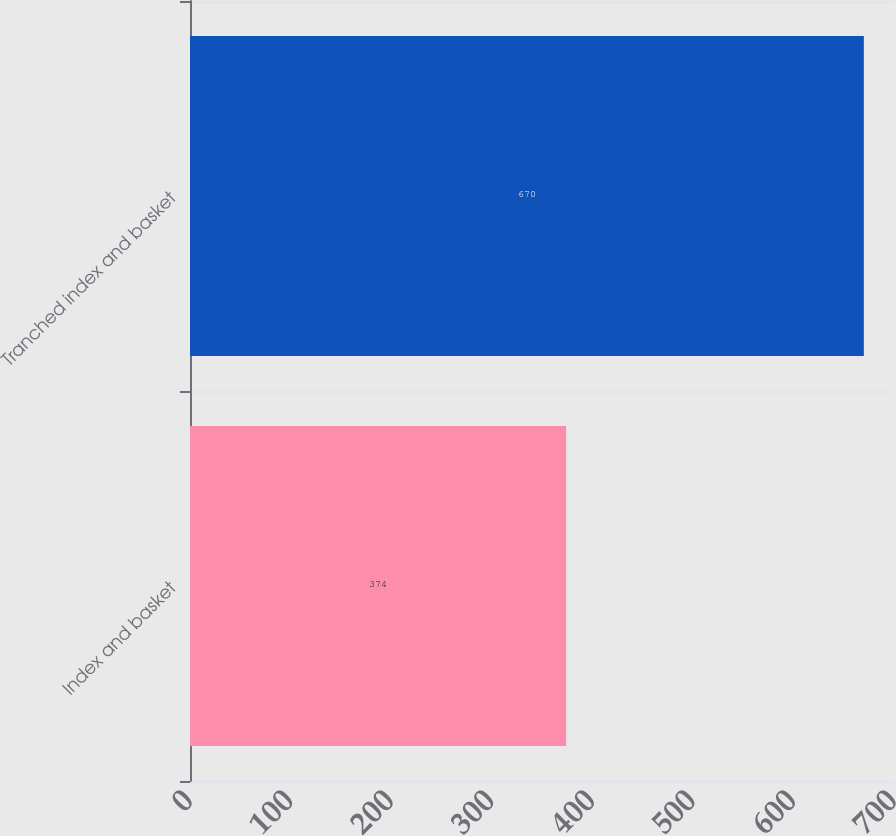Convert chart to OTSL. <chart><loc_0><loc_0><loc_500><loc_500><bar_chart><fcel>Index and basket<fcel>Tranched index and basket<nl><fcel>374<fcel>670<nl></chart> 